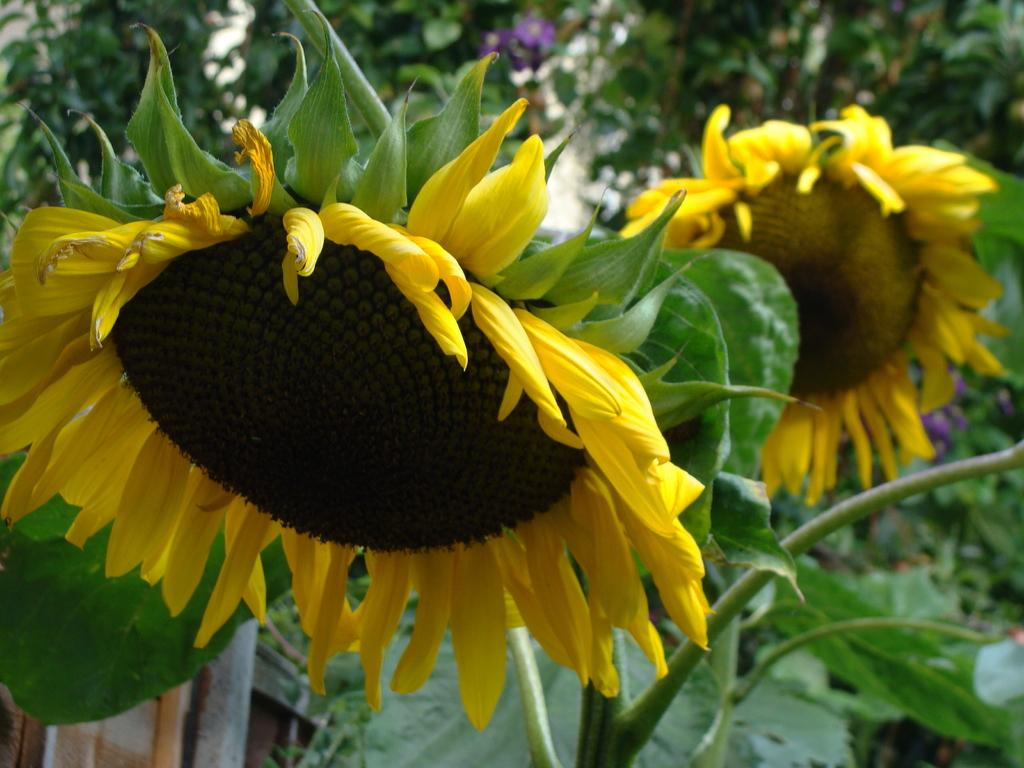What types of flowers are in the foreground of the image? There are 2 sunflowers in the foreground of the image. What else can be seen in the image besides the sunflowers? There are plants in the background of the image. How is the background of the image depicted? The background appears blurred. Where is the monkey sitting in the image? There is no monkey present in the image. What type of wire is used to hold the plate in the image? There is no plate or wire present in the image. 